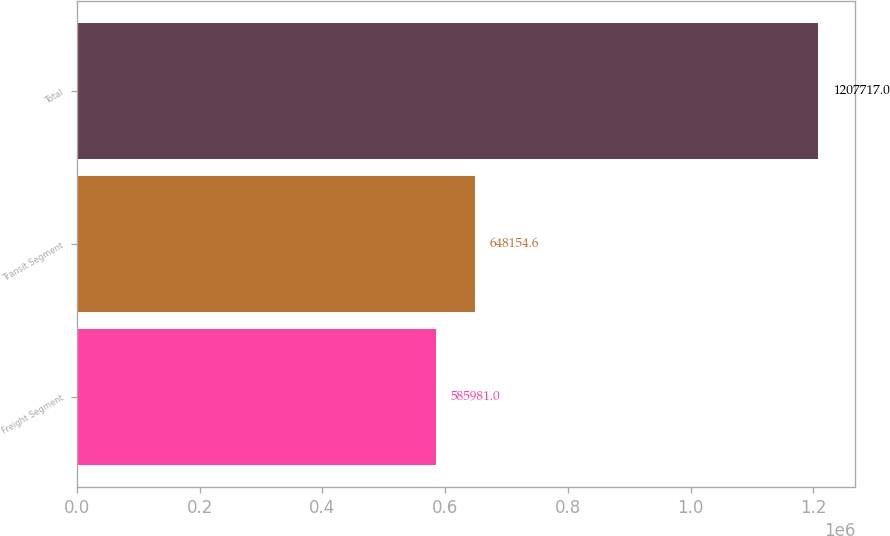<chart> <loc_0><loc_0><loc_500><loc_500><bar_chart><fcel>Freight Segment<fcel>Transit Segment<fcel>Total<nl><fcel>585981<fcel>648155<fcel>1.20772e+06<nl></chart> 